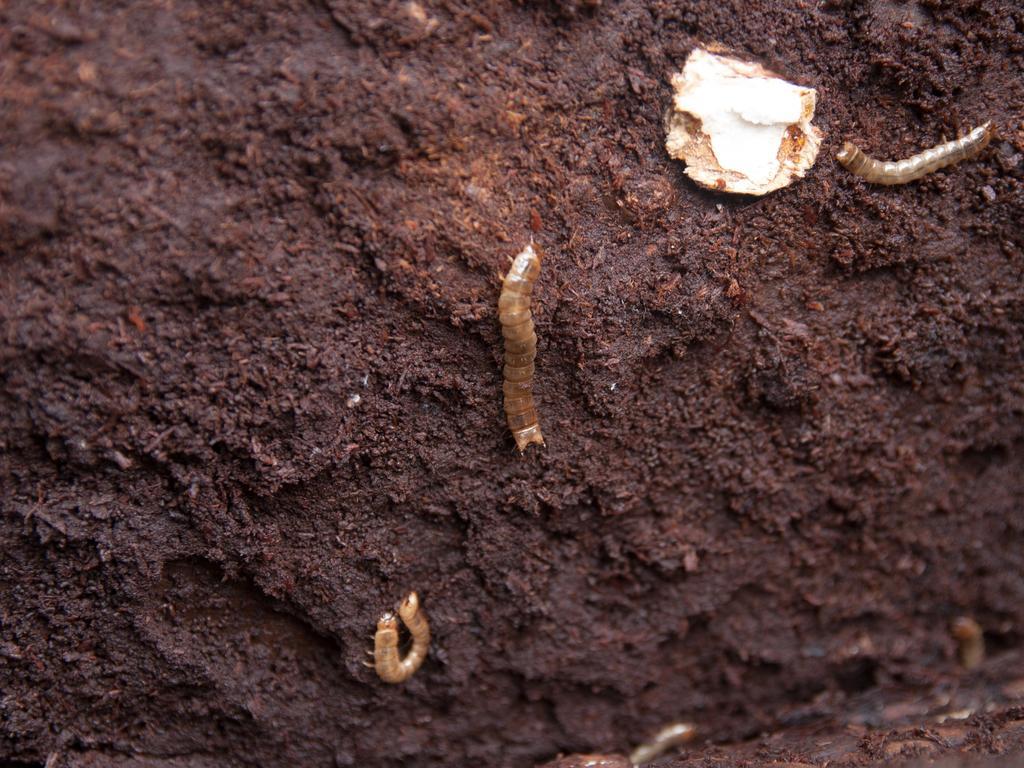Can you describe this image briefly? At the bottom I can see the ground. In this image I can see the worms. The background seems to be the mud. 